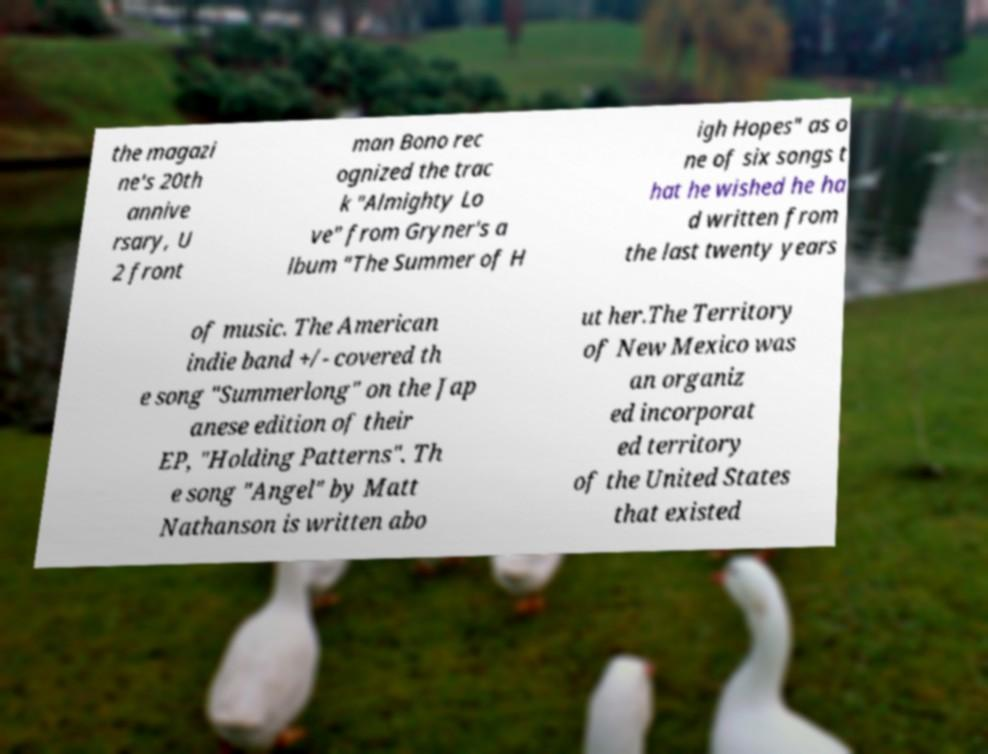For documentation purposes, I need the text within this image transcribed. Could you provide that? the magazi ne's 20th annive rsary, U 2 front man Bono rec ognized the trac k "Almighty Lo ve" from Gryner's a lbum "The Summer of H igh Hopes" as o ne of six songs t hat he wished he ha d written from the last twenty years of music. The American indie band +/- covered th e song "Summerlong" on the Jap anese edition of their EP, "Holding Patterns". Th e song "Angel" by Matt Nathanson is written abo ut her.The Territory of New Mexico was an organiz ed incorporat ed territory of the United States that existed 